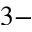<formula> <loc_0><loc_0><loc_500><loc_500>3 -</formula> 